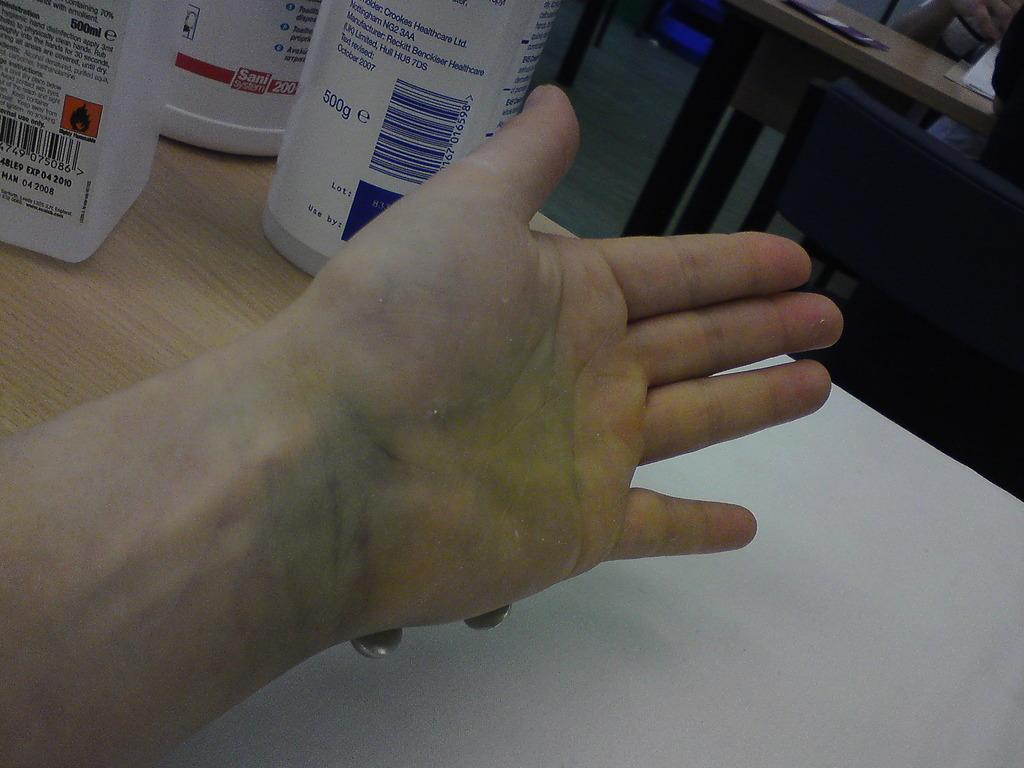What is the main subject of the image? There is a person's hand in the image. What can be seen in the background of the image? There are disposable bottles on a table and persons sitting on chairs in the background. What type of cloth is being used to clean the dust in the image? There is no cloth or dust present in the image. How does the wind affect the persons sitting on chairs in the image? There is no wind present in the image, and therefore its effect on the persons sitting on chairs cannot be determined. 